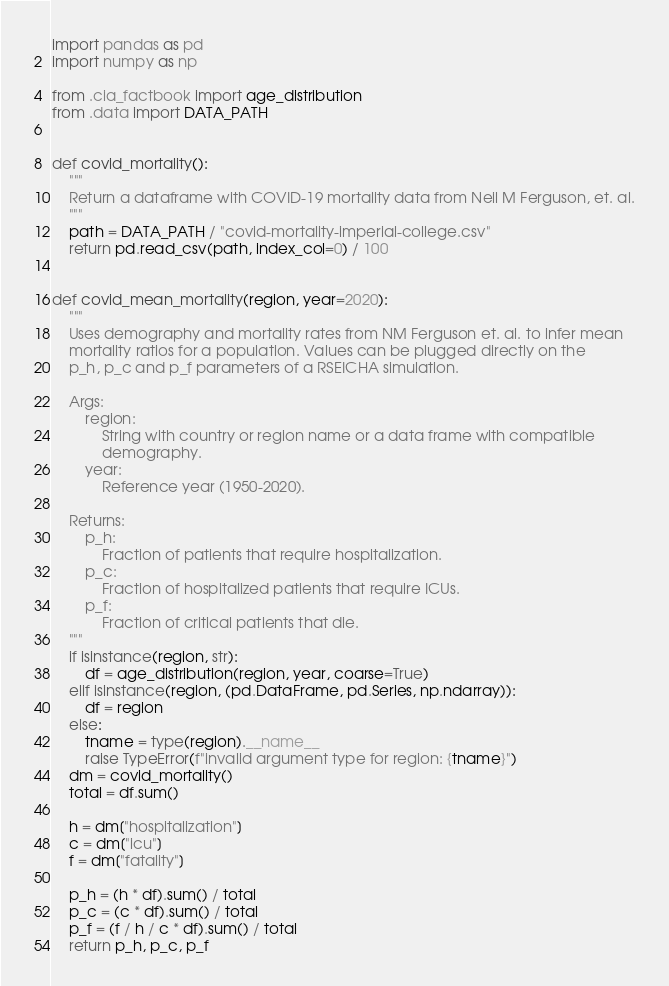Convert code to text. <code><loc_0><loc_0><loc_500><loc_500><_Python_>import pandas as pd
import numpy as np

from .cia_factbook import age_distribution
from .data import DATA_PATH


def covid_mortality():
    """
    Return a dataframe with COVID-19 mortality data from Neil M Ferguson, et. al.
    """
    path = DATA_PATH / "covid-mortality-imperial-college.csv"
    return pd.read_csv(path, index_col=0) / 100


def covid_mean_mortality(region, year=2020):
    """
    Uses demography and mortality rates from NM Ferguson et. al. to infer mean
    mortality ratios for a population. Values can be plugged directly on the
    p_h, p_c and p_f parameters of a RSEICHA simulation.

    Args:
        region:
            String with country or region name or a data frame with compatible
            demography.
        year:
            Reference year (1950-2020).

    Returns:
        p_h:
            Fraction of patients that require hospitalization.
        p_c:
            Fraction of hospitalized patients that require ICUs.
        p_f:
            Fraction of critical patients that die.
    """
    if isinstance(region, str):
        df = age_distribution(region, year, coarse=True)
    elif isinstance(region, (pd.DataFrame, pd.Series, np.ndarray)):
        df = region
    else:
        tname = type(region).__name__
        raise TypeError(f"invalid argument type for region: {tname}")
    dm = covid_mortality()
    total = df.sum()

    h = dm["hospitalization"]
    c = dm["icu"]
    f = dm["fatality"]

    p_h = (h * df).sum() / total
    p_c = (c * df).sum() / total
    p_f = (f / h / c * df).sum() / total
    return p_h, p_c, p_f
</code> 